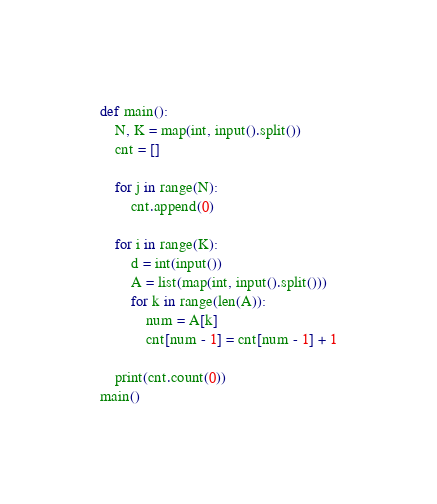Convert code to text. <code><loc_0><loc_0><loc_500><loc_500><_Python_>def main():
    N, K = map(int, input().split())
    cnt = []

    for j in range(N):
        cnt.append(0)
    
    for i in range(K):
        d = int(input())
        A = list(map(int, input().split()))
        for k in range(len(A)):
            num = A[k]
            cnt[num - 1] = cnt[num - 1] + 1
    
    print(cnt.count(0))
main()</code> 